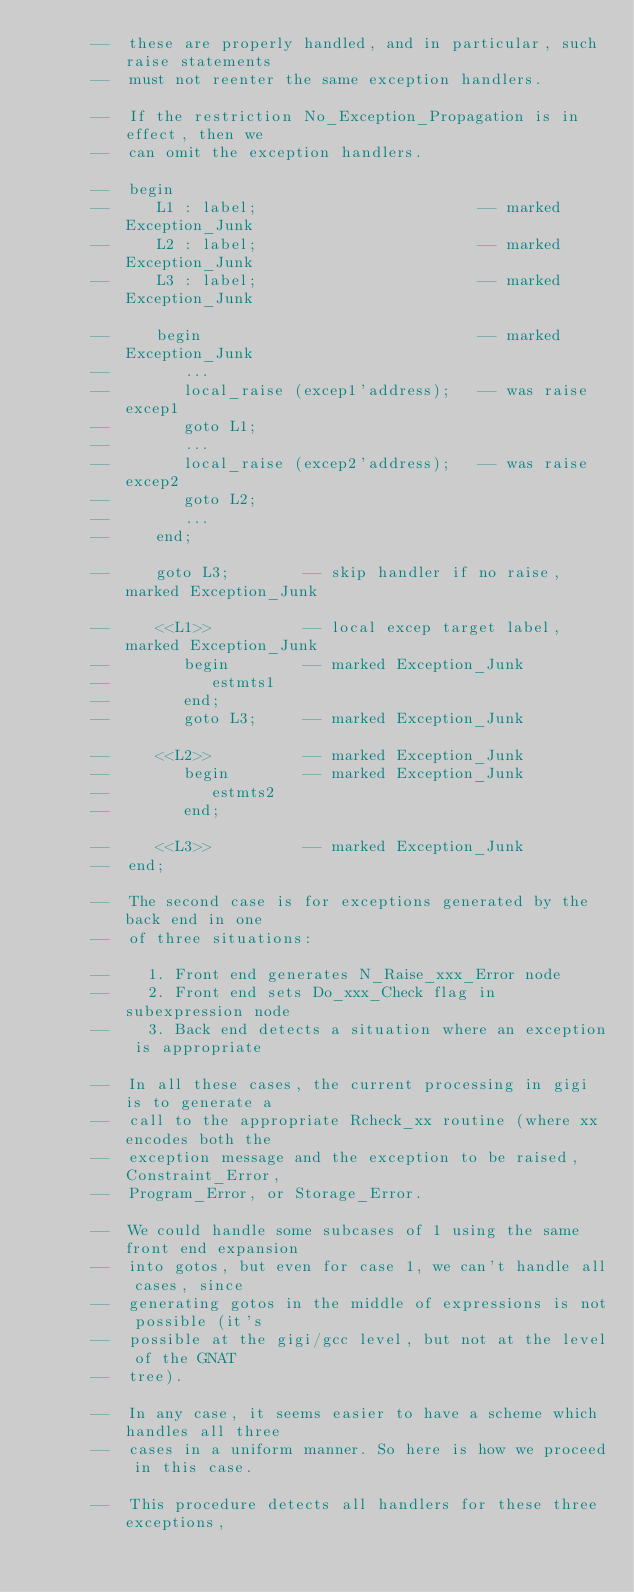Convert code to text. <code><loc_0><loc_0><loc_500><loc_500><_Ada_>      --  these are properly handled, and in particular, such raise statements
      --  must not reenter the same exception handlers.

      --  If the restriction No_Exception_Propagation is in effect, then we
      --  can omit the exception handlers.

      --  begin
      --     L1 : label;                        -- marked Exception_Junk
      --     L2 : label;                        -- marked Exception_Junk
      --     L3 : label;                        -- marked Exception_Junk

      --     begin                              -- marked Exception_Junk
      --        ...
      --        local_raise (excep1'address);   -- was raise excep1
      --        goto L1;
      --        ...
      --        local_raise (excep2'address);   -- was raise excep2
      --        goto L2;
      --        ...
      --     end;

      --     goto L3;        -- skip handler if no raise, marked Exception_Junk

      --     <<L1>>          -- local excep target label, marked Exception_Junk
      --        begin        -- marked Exception_Junk
      --           estmts1
      --        end;
      --        goto L3;     -- marked Exception_Junk

      --     <<L2>>          -- marked Exception_Junk
      --        begin        -- marked Exception_Junk
      --           estmts2
      --        end;

      --     <<L3>>          -- marked Exception_Junk
      --  end;

      --  The second case is for exceptions generated by the back end in one
      --  of three situations:

      --    1. Front end generates N_Raise_xxx_Error node
      --    2. Front end sets Do_xxx_Check flag in subexpression node
      --    3. Back end detects a situation where an exception is appropriate

      --  In all these cases, the current processing in gigi is to generate a
      --  call to the appropriate Rcheck_xx routine (where xx encodes both the
      --  exception message and the exception to be raised, Constraint_Error,
      --  Program_Error, or Storage_Error.

      --  We could handle some subcases of 1 using the same front end expansion
      --  into gotos, but even for case 1, we can't handle all cases, since
      --  generating gotos in the middle of expressions is not possible (it's
      --  possible at the gigi/gcc level, but not at the level of the GNAT
      --  tree).

      --  In any case, it seems easier to have a scheme which handles all three
      --  cases in a uniform manner. So here is how we proceed in this case.

      --  This procedure detects all handlers for these three exceptions,</code> 